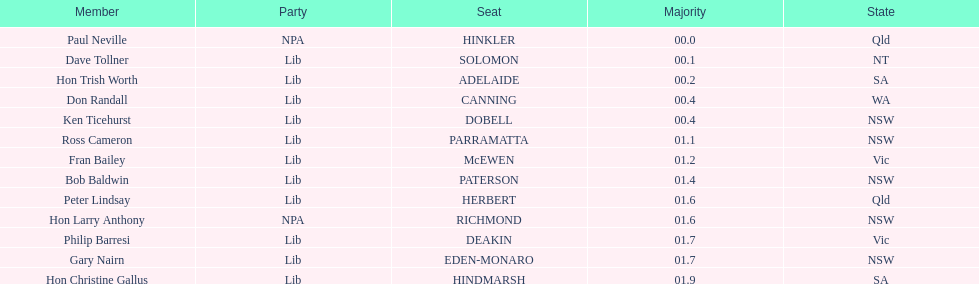What is the total of seats? 13. 